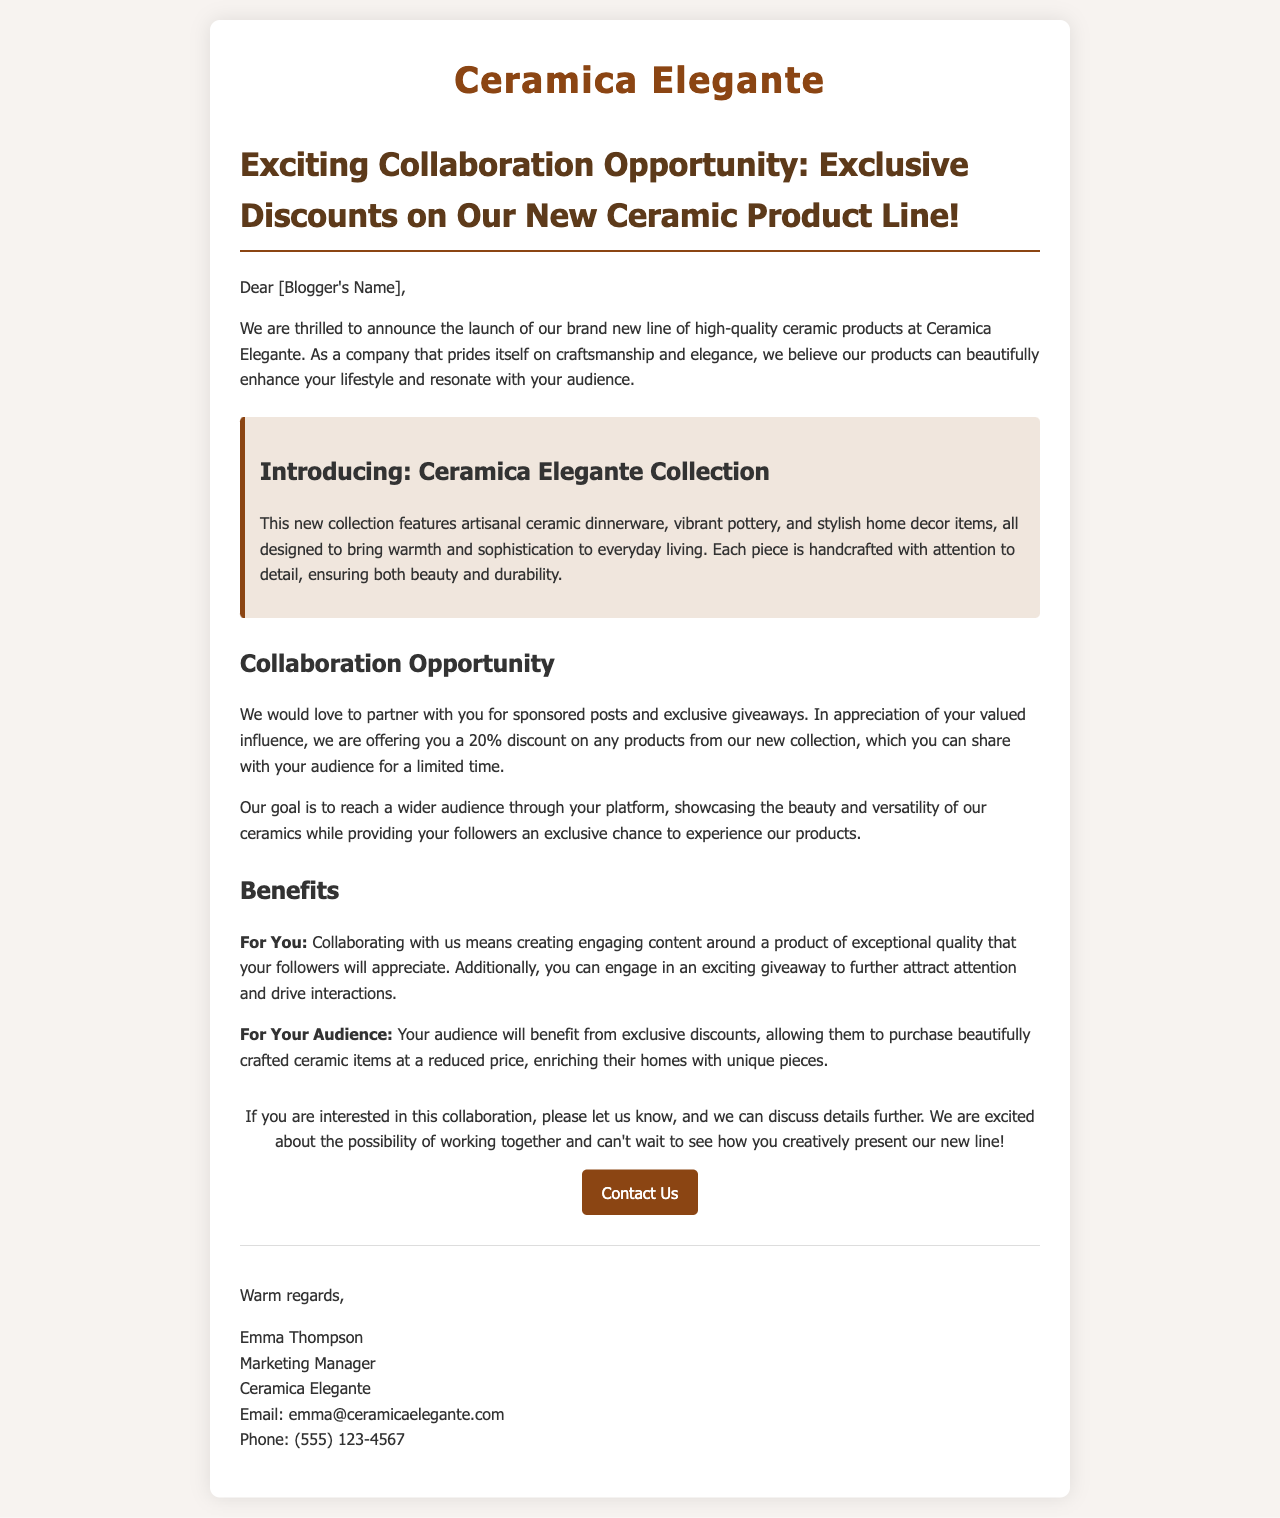What is the name of the company? The name of the company mentioned in the document is Ceramica Elegante.
Answer: Ceramica Elegante Who is the Marketing Manager? The document states that Emma Thompson is the Marketing Manager.
Answer: Emma Thompson What discount is offered to the bloggers? The letter highlights a 20% discount for bloggers on the new collection.
Answer: 20% What type of products are introduced in the new collection? The document describes the new collection as artisanal ceramic dinnerware, vibrant pottery, and stylish home decor items.
Answer: Ceramic dinnerware, pottery, home decor What is the primary goal of the collaboration? The letter mentions the goal of reaching a wider audience through the blogger's platform.
Answer: Reach a wider audience What will bloggers gain from this collaboration? Bloggers will create engaging content around a product of exceptional quality and have the opportunity for a giveaway.
Answer: Engaging content and giveaway What is the email address provided for contact? The contact email provided in the document is emma@ceramicaelegante.com.
Answer: emma@ceramicaelegante.com How should the bloggers respond if interested? The document invites bloggers to let the company know if they are interested for further discussion.
Answer: Let us know What is the visual theme of the document? The document uses a warm and elegant color scheme with a focus on sophistication.
Answer: Warm and elegant 